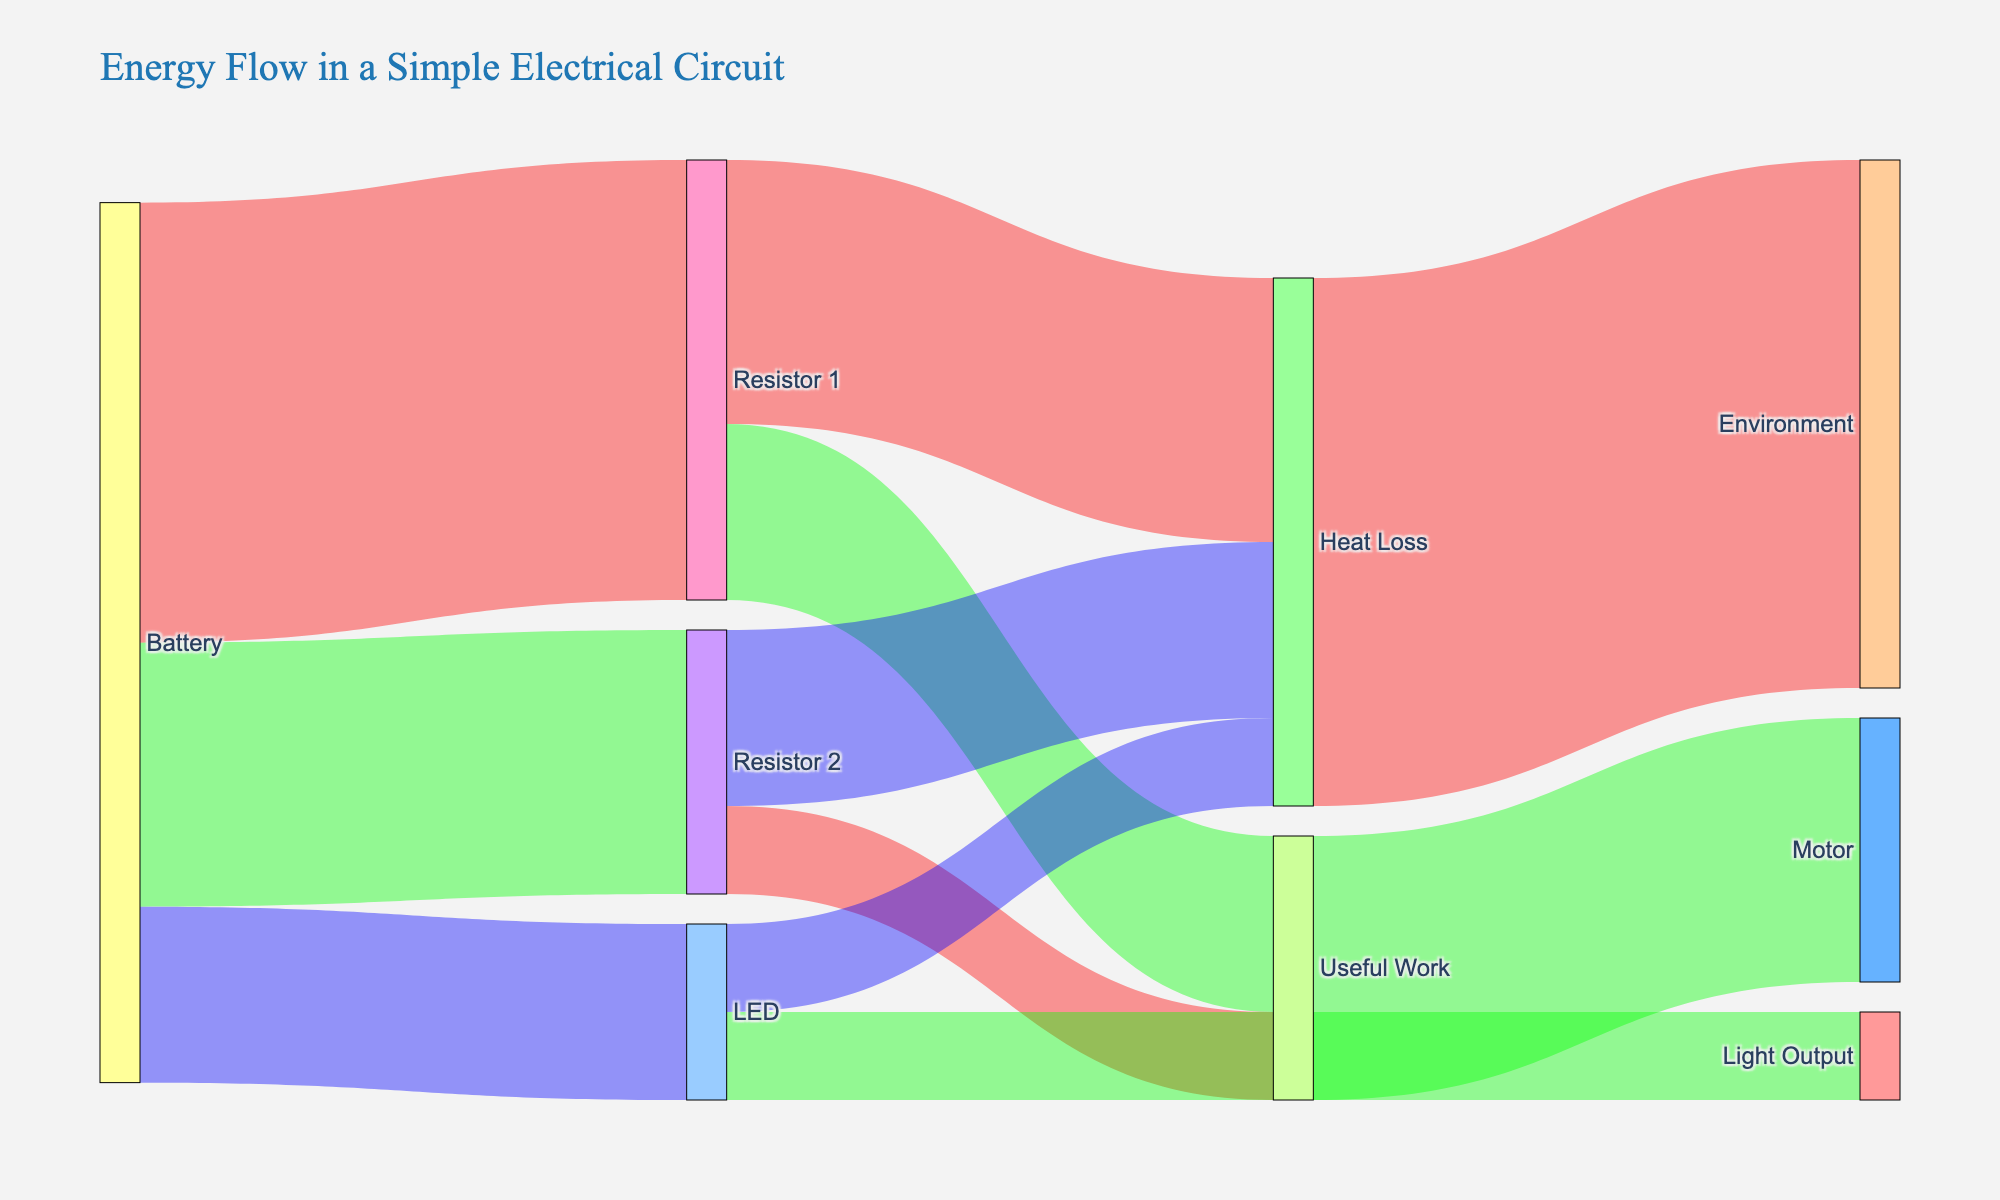What is the title of the figure? The title is located at the top of the figure and usually summarizes the content, which in this case is specifically about the energy flow in an electrical circuit.
Answer: Energy Flow in a Simple Electrical Circuit How many different nodes (components) are displayed in the diagram? Count all the unique labels representing components of the circuit such as Battery, Resistor 1, Resistor 2, LED, etc.
Answer: 10 What is the total amount of energy flowing from the Battery? Sum the values of all connections (links) originating from the Battery. This includes 5 (Resistor 1) + 3 (Resistor 2) + 2 (LED).
Answer: 10 Which component receives the least amount of energy from the Battery? Compare the values of energy flowing to Resistor 1, Resistor 2, and LED from the Battery. The smallest value is associated with the target that receives the least energy.
Answer: LED What is the proportion of energy that ends up as Heat Loss overall? Add the values of links leading to Heat Loss from each node (Resistor 1, Resistor 2, and LED) and divide by the total energy. (3 + 2 + 1) / 10.
Answer: 60% How does the energy output of LED compare to Resistor 1 in terms of useful work? Compare the values of energy categorized as Useful Work from both the LED and Resistor 1.
Answer: LED outputs less useful work (1 vs. 2 from Resistor 1) What is the total energy that ends up in the environment? Sum the values of all links pointing to the Environment. This is the value of Heat Loss link (6).
Answer: 6 Between Resistor 1 and Resistor 2, which converts a larger percentage of its energy into heat? Calculate the percentage of energy converted to heat in both Resistor 1 and Resistor 2. For Resistor 1: (3/5) = 60%, for Resistor 2: (2/3) ≈ 66.67%.
Answer: Resistor 2 Which node converts all its incoming energy to a single output type, and what is that output? Check each node to see if it has a single outgoing link and identify the corresponding output. Environment, with all incoming energy being heat loss.
Answer: Environment -> Heat Loss 